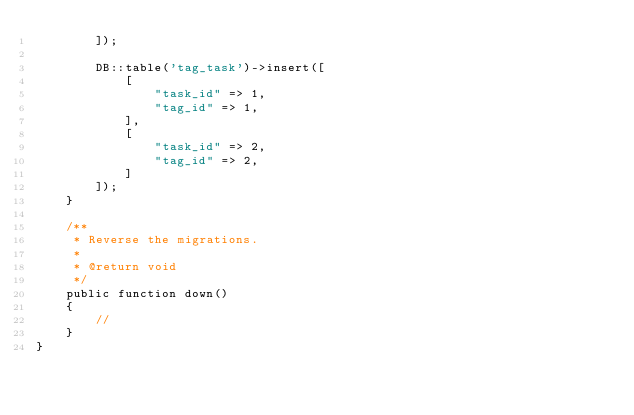Convert code to text. <code><loc_0><loc_0><loc_500><loc_500><_PHP_>        ]);

        DB::table('tag_task')->insert([
            [
                "task_id" => 1,
                "tag_id" => 1,
            ],
            [
                "task_id" => 2,
                "tag_id" => 2,
            ]
        ]);
    }

    /**
     * Reverse the migrations.
     *
     * @return void
     */
    public function down()
    {
        //
    }
}
</code> 